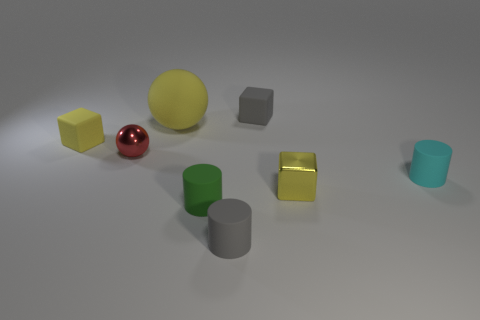Add 1 small red shiny things. How many objects exist? 9 Subtract all rubber cubes. How many cubes are left? 1 Subtract 1 balls. How many balls are left? 1 Subtract all brown balls. How many yellow cubes are left? 2 Subtract all green cylinders. How many cylinders are left? 2 Subtract 1 red spheres. How many objects are left? 7 Subtract all blocks. How many objects are left? 5 Subtract all blue cubes. Subtract all cyan cylinders. How many cubes are left? 3 Subtract all green cylinders. Subtract all tiny objects. How many objects are left? 0 Add 8 red metallic things. How many red metallic things are left? 9 